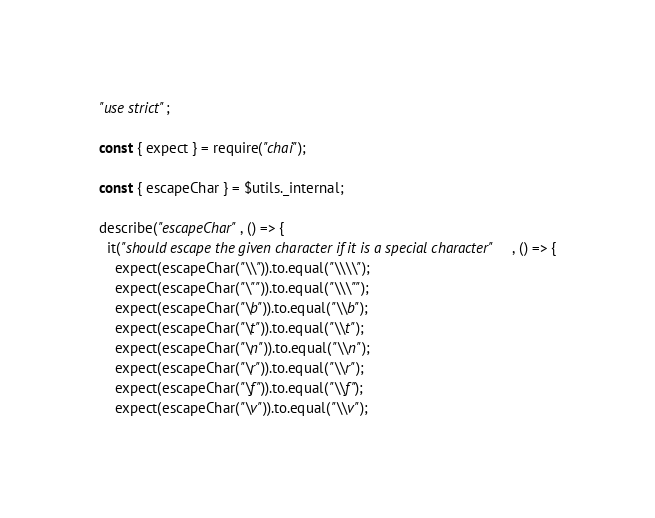Convert code to text. <code><loc_0><loc_0><loc_500><loc_500><_JavaScript_>"use strict";

const { expect } = require("chai");

const { escapeChar } = $utils._internal;

describe("escapeChar", () => {
  it("should escape the given character if it is a special character", () => {
    expect(escapeChar("\\")).to.equal("\\\\");
    expect(escapeChar("\"")).to.equal("\\\"");
    expect(escapeChar("\b")).to.equal("\\b");
    expect(escapeChar("\t")).to.equal("\\t");
    expect(escapeChar("\n")).to.equal("\\n");
    expect(escapeChar("\r")).to.equal("\\r");
    expect(escapeChar("\f")).to.equal("\\f");
    expect(escapeChar("\v")).to.equal("\\v");</code> 